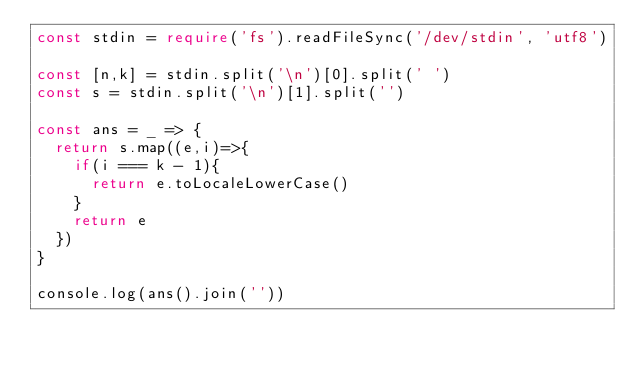<code> <loc_0><loc_0><loc_500><loc_500><_TypeScript_>const stdin = require('fs').readFileSync('/dev/stdin', 'utf8')

const [n,k] = stdin.split('\n')[0].split(' ')
const s = stdin.split('\n')[1].split('')

const ans = _ => {
  return s.map((e,i)=>{
    if(i === k - 1){
      return e.toLocaleLowerCase()
    }
    return e
  })
}

console.log(ans().join(''))
</code> 